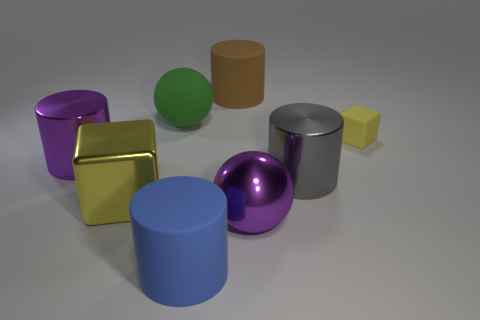Add 1 big brown matte objects. How many objects exist? 9 Subtract all spheres. How many objects are left? 6 Add 2 gray rubber things. How many gray rubber things exist? 2 Subtract 1 brown cylinders. How many objects are left? 7 Subtract all large yellow metal objects. Subtract all large brown rubber things. How many objects are left? 6 Add 4 big metallic cylinders. How many big metallic cylinders are left? 6 